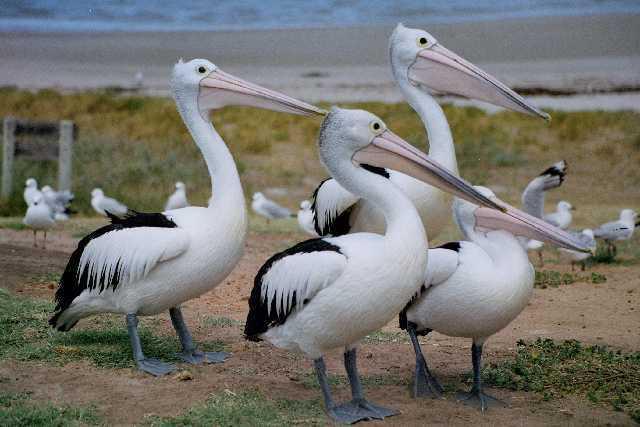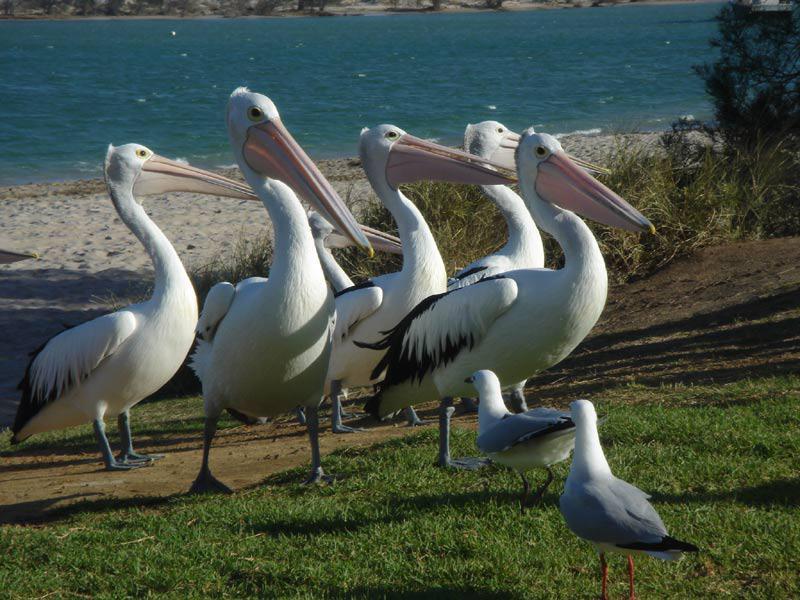The first image is the image on the left, the second image is the image on the right. Considering the images on both sides, is "In the image on the right, you can see exactly three of the birds, as there are none in the background." valid? Answer yes or no. No. The first image is the image on the left, the second image is the image on the right. Evaluate the accuracy of this statement regarding the images: "There is at least three pelicans standing outside.". Is it true? Answer yes or no. Yes. 